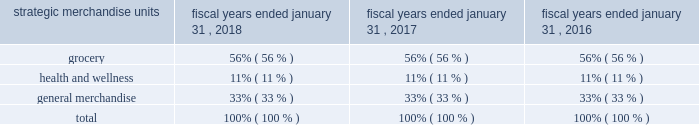Services like "walmart pickup" "pickup today" and in over 1100 "online grocery" pickup locations to provide an omni- channel offering to our customers .
Walmart u.s .
Also offers access to digital content and services including vudu .
Merchandise .
Walmart u.s .
Does business in three strategic merchandise units , listed below , across several store formats including supercenters , discount stores , neighborhood markets and other small store formats , as well as on our ecommerce websites .
2022 grocery consists of a full line of grocery items , including meat , produce , natural & organics , deli & bakery , dairy , frozen foods , alcoholic and nonalcoholic beverages , floral and dry grocery , as well as consumables such as health and beauty aids , baby products , household chemicals , paper goods and pet supplies ; 2022 health and wellness includes pharmacy , optical services , clinical services , and over-the-counter drugs and other medical products ; 2022 general merchandise includes : 25e6 entertainment ( e.g. , electronics , cameras and supplies , photo processing services , wireless , movies , music , video games and books ) ; 25e6 hardlines ( e.g. , stationery , automotive , hardware and paint , sporting goods , outdoor living and horticulture ) ; 25e6 apparel ( e.g. , apparel for women , girls , men , boys and infants , as well as shoes , jewelry and accessories ) ; and 25e6 home/seasonal ( e.g. , home furnishings , housewares and small appliances , bedding , home decor , toys , fabrics and crafts and seasonal merchandise ) .
Walmart u.s .
Also offers fuel and financial services and related products , including money orders , prepaid cards , wire transfers , money transfers , check cashing and bill payment .
These services total less than 1% ( 1 % ) of annual net sales .
Brand name merchandise represents a significant portion of the merchandise sold in walmart u.s .
We also market lines of merchandise under our private-label store brands , including : "adventure force" "autodrive" "blackweb" "equate" "everstart" "faded glory" "george" "great value" "holiday time" "hyper tough" "kid connection" "mainstays" "marketside" "my life as" "no boundaries" "ol' roy" "onn" "ozark trail" "parent's choice" "prima della" "pure balance" "sam's choice" "special kitty" "spring valley" "terra & sky" "time and tru" "way to celebrate" and "wonder nation." the company also markets lines of merchandise under licensed brands , some of which include : "better homes a0& gardens" "farberware" "russell" and "swisstech." the percentage of strategic merchandise unit net sales for walmart u.s. , including online sales , was as follows for fiscal 2018 , 2017 and 2016: .
Periodically , revisions are made to the categorization of the components comprising our strategic merchandise units .
When revisions are made , the previous periods' presentation is adjusted to maintain comparability .
Operations .
Many supercenters , discount stores and neighborhood markets are open 24 hours each day .
A variety of payment methods are accepted at our stores and through our ecommerce websites and mobile commerce applications .
Seasonal aspects of operations .
Walmart u.s.'s business is seasonal to a certain extent due to calendar events and national and religious holidays , as well as different weather patterns .
Historically , its highest sales volume and segment operating income have occurred in the fiscal quarter ending january a031 .
Competition .
Walmart u.s .
Competes with both physical retailers operating discount , department , retail and wholesale grocers , drug , dollar , variety and specialty stores , supermarkets , hypermarkets and supercenter-type stores , and digital retailers , as well as catalog businesses .
We also compete with others for desirable sites for new or relocated retail units .
Our ability to develop , open and operate units at the right locations and to deliver a customer-centric omni-channel experience largely determines our competitive position within the retail industry .
We employ many programs designed to meet competitive pressures within our industry .
These programs include the following : 2022 edlp : our pricing philosophy under which we price items at a low price every day so our customers trust that our prices will not change under frequent promotional activity ; 2022 edlc : everyday low cost is our commitment to control expenses so our cost savings can be passed along to our customers; .
In 2018 as part of the strategic merchandise what was the ration of the grocery to the health and wellness products? 
Computations: (56 / 11)
Answer: 5.09091. 